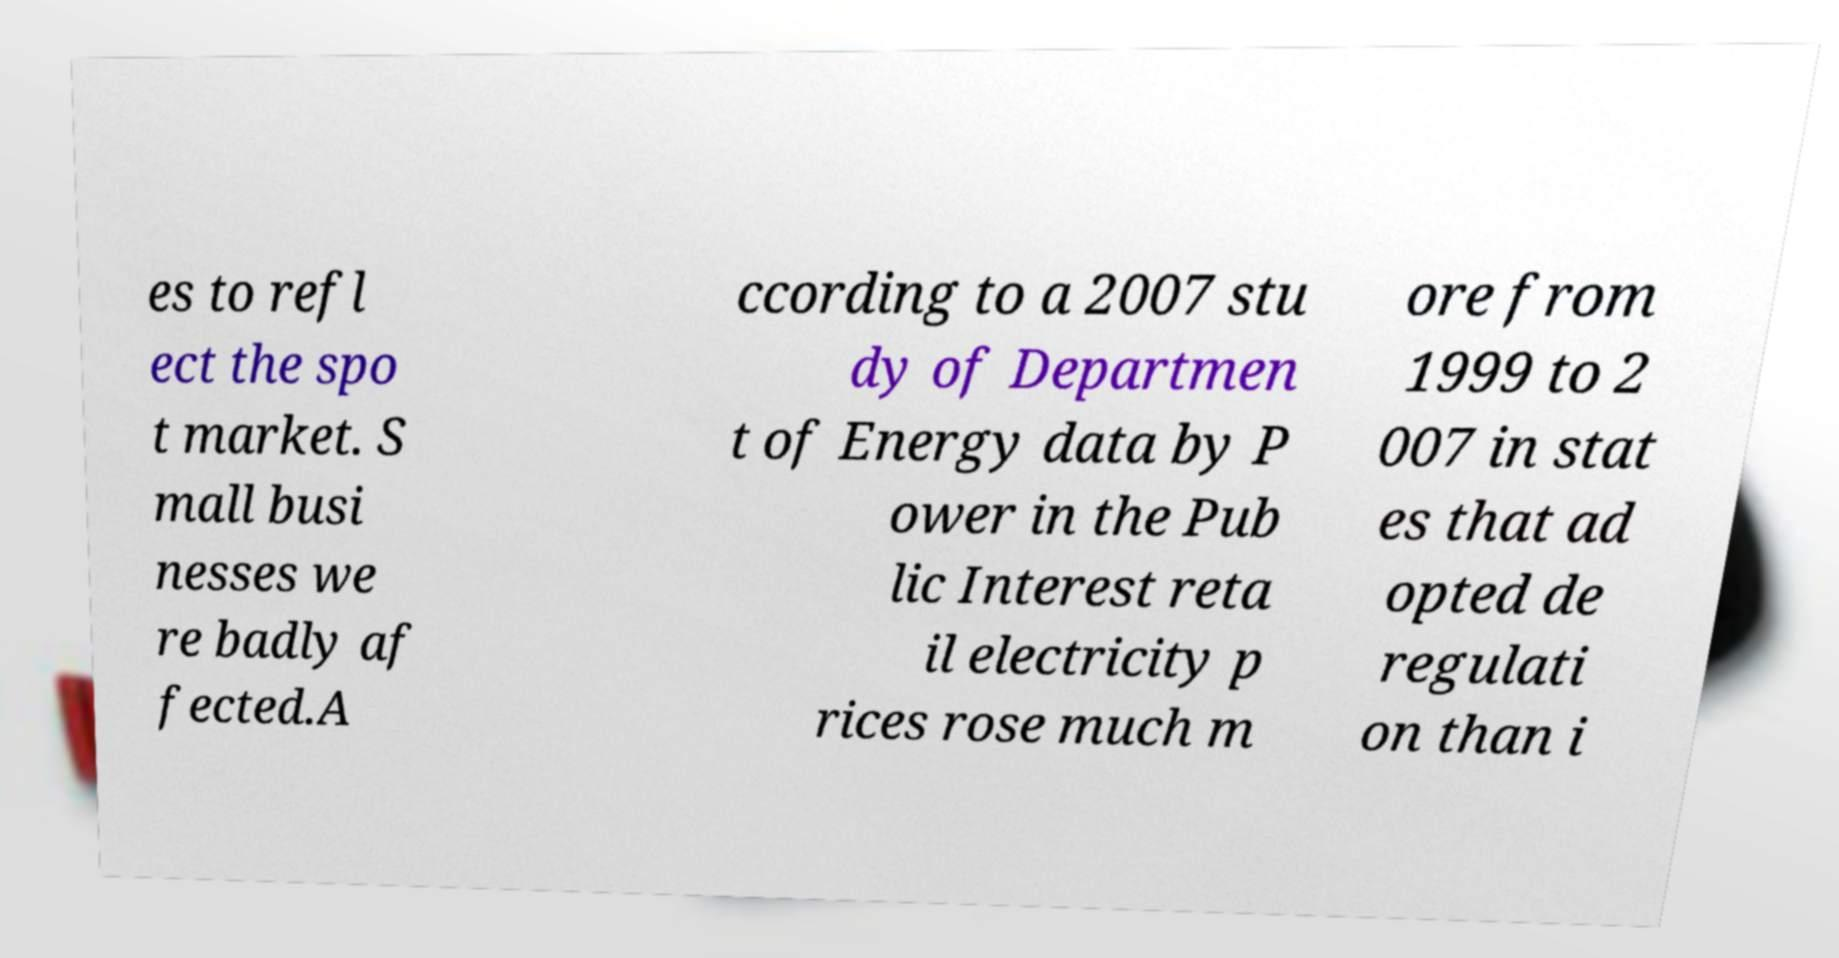What messages or text are displayed in this image? I need them in a readable, typed format. es to refl ect the spo t market. S mall busi nesses we re badly af fected.A ccording to a 2007 stu dy of Departmen t of Energy data by P ower in the Pub lic Interest reta il electricity p rices rose much m ore from 1999 to 2 007 in stat es that ad opted de regulati on than i 